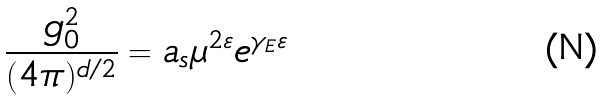<formula> <loc_0><loc_0><loc_500><loc_500>\frac { g _ { 0 } ^ { 2 } } { ( 4 \pi ) ^ { d / 2 } } = a _ { s } \mu ^ { 2 \varepsilon } e ^ { \gamma _ { E } \varepsilon }</formula> 